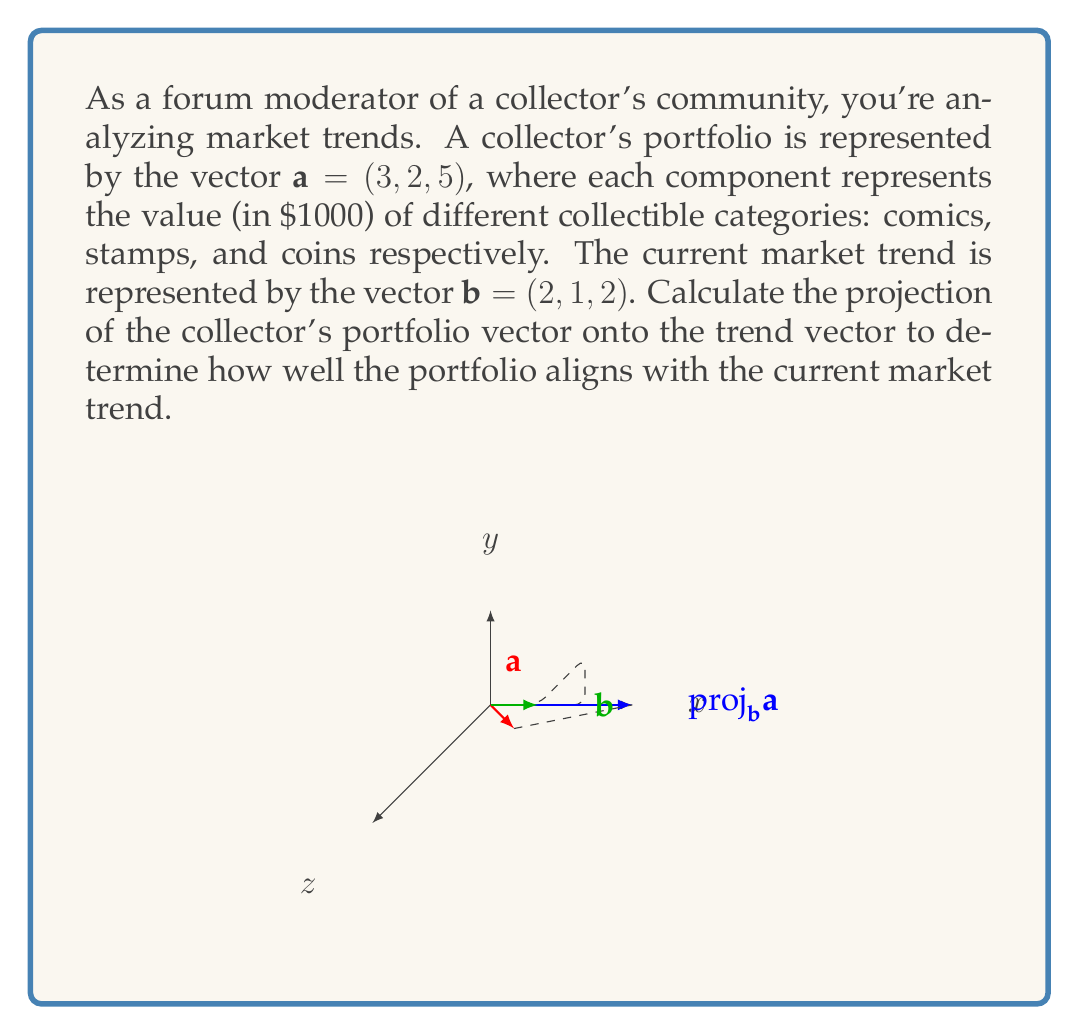Help me with this question. To compute the projection of vector $\mathbf{a}$ onto vector $\mathbf{b}$, we'll use the formula:

$$\text{proj}_\mathbf{b}\mathbf{a} = \frac{\mathbf{a} \cdot \mathbf{b}}{\|\mathbf{b}\|^2} \mathbf{b}$$

Step 1: Calculate the dot product $\mathbf{a} \cdot \mathbf{b}$
$$\mathbf{a} \cdot \mathbf{b} = (3)(2) + (2)(1) + (5)(2) = 6 + 2 + 10 = 18$$

Step 2: Calculate the magnitude of $\mathbf{b}$ squared
$$\|\mathbf{b}\|^2 = 2^2 + 1^2 + 2^2 = 4 + 1 + 4 = 9$$

Step 3: Calculate the scalar projection
$$\frac{\mathbf{a} \cdot \mathbf{b}}{\|\mathbf{b}\|^2} = \frac{18}{9} = 2$$

Step 4: Multiply the scalar projection by $\mathbf{b}$ to get the vector projection
$$\text{proj}_\mathbf{b}\mathbf{a} = 2\mathbf{b} = 2(2, 1, 2) = (4, 2, 4)$$

This result shows how the collector's portfolio aligns with the current market trend. The projection vector $(4, 2, 4)$ indicates the component of the portfolio that is in the direction of the trend.
Answer: $(4, 2, 4)$ 